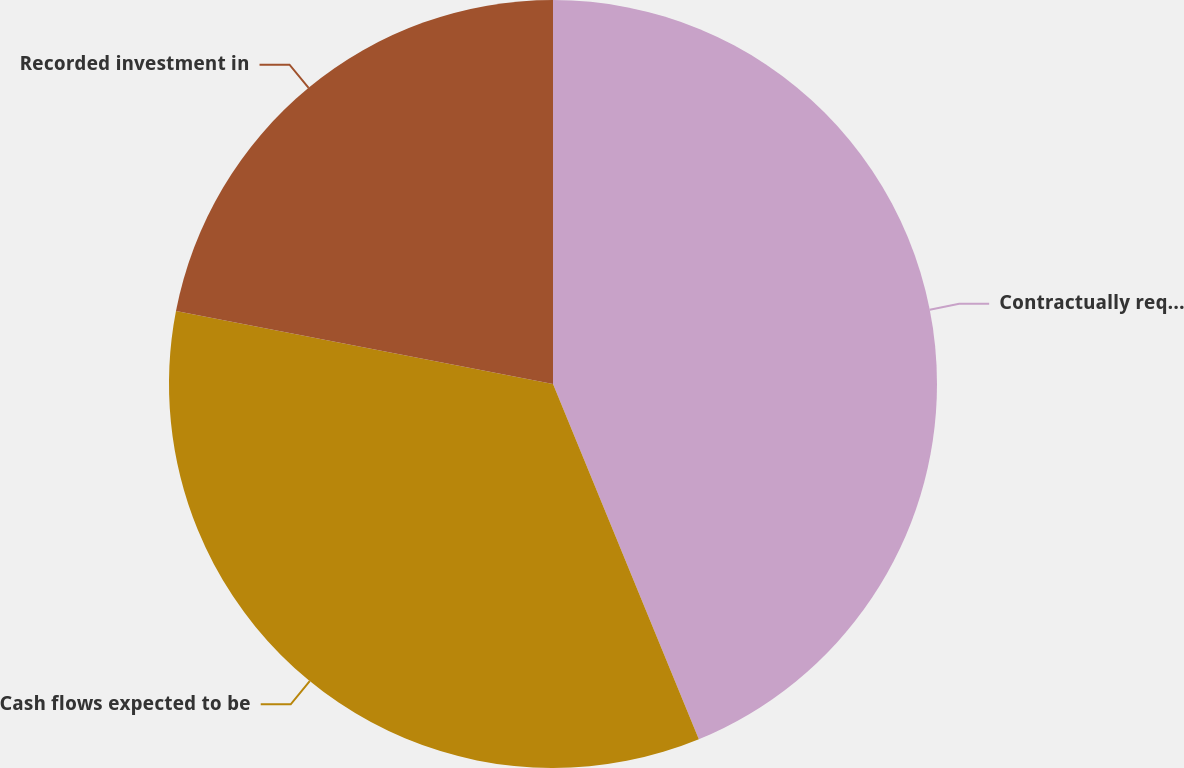<chart> <loc_0><loc_0><loc_500><loc_500><pie_chart><fcel>Contractually required<fcel>Cash flows expected to be<fcel>Recorded investment in<nl><fcel>43.8%<fcel>34.24%<fcel>21.96%<nl></chart> 